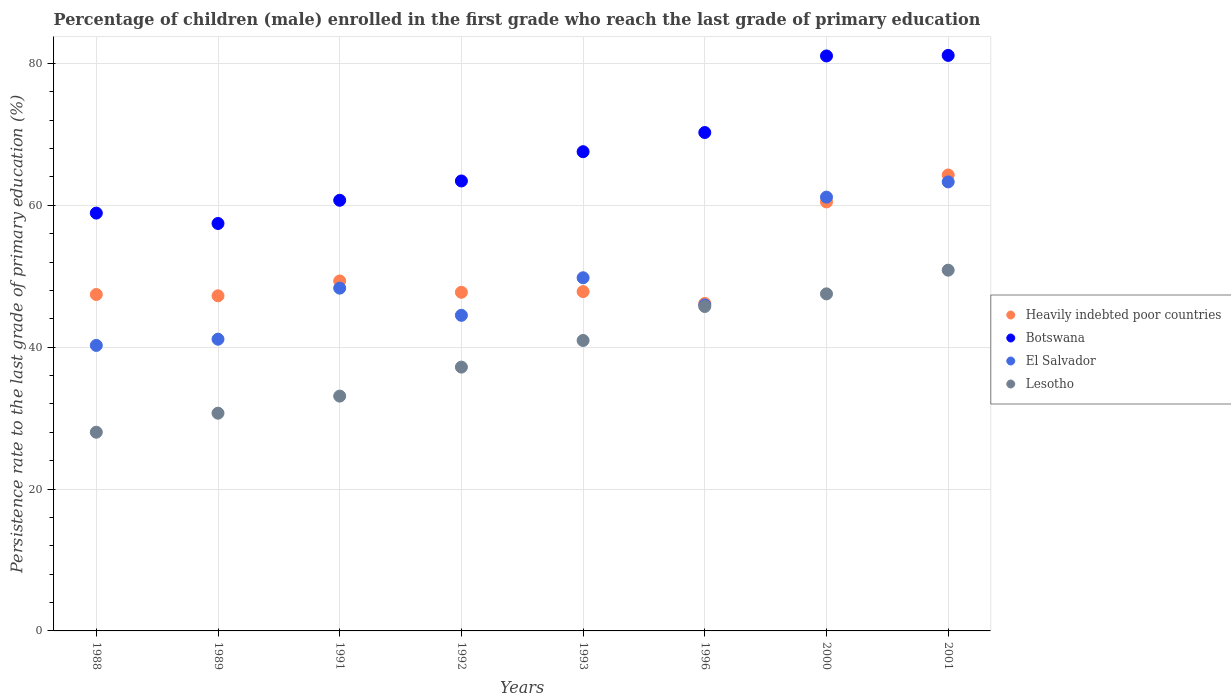How many different coloured dotlines are there?
Ensure brevity in your answer.  4. What is the persistence rate of children in Heavily indebted poor countries in 1988?
Your response must be concise. 47.42. Across all years, what is the maximum persistence rate of children in Heavily indebted poor countries?
Give a very brief answer. 64.27. Across all years, what is the minimum persistence rate of children in Lesotho?
Your answer should be compact. 28.01. In which year was the persistence rate of children in El Salvador maximum?
Give a very brief answer. 2001. In which year was the persistence rate of children in Lesotho minimum?
Ensure brevity in your answer.  1988. What is the total persistence rate of children in Heavily indebted poor countries in the graph?
Your response must be concise. 410.46. What is the difference between the persistence rate of children in Lesotho in 1991 and that in 1992?
Ensure brevity in your answer.  -4.09. What is the difference between the persistence rate of children in El Salvador in 1991 and the persistence rate of children in Botswana in 2001?
Give a very brief answer. -32.81. What is the average persistence rate of children in El Salvador per year?
Provide a succinct answer. 49.29. In the year 2000, what is the difference between the persistence rate of children in El Salvador and persistence rate of children in Heavily indebted poor countries?
Make the answer very short. 0.68. In how many years, is the persistence rate of children in Botswana greater than 76 %?
Provide a short and direct response. 2. What is the ratio of the persistence rate of children in Heavily indebted poor countries in 1988 to that in 1989?
Give a very brief answer. 1. What is the difference between the highest and the second highest persistence rate of children in Lesotho?
Your answer should be very brief. 3.34. What is the difference between the highest and the lowest persistence rate of children in Botswana?
Offer a terse response. 23.69. In how many years, is the persistence rate of children in Lesotho greater than the average persistence rate of children in Lesotho taken over all years?
Give a very brief answer. 4. Is the sum of the persistence rate of children in Heavily indebted poor countries in 1988 and 2000 greater than the maximum persistence rate of children in El Salvador across all years?
Offer a terse response. Yes. Is it the case that in every year, the sum of the persistence rate of children in Lesotho and persistence rate of children in Botswana  is greater than the sum of persistence rate of children in El Salvador and persistence rate of children in Heavily indebted poor countries?
Give a very brief answer. No. Does the persistence rate of children in El Salvador monotonically increase over the years?
Keep it short and to the point. No. Is the persistence rate of children in Heavily indebted poor countries strictly greater than the persistence rate of children in Botswana over the years?
Give a very brief answer. No. Is the persistence rate of children in Lesotho strictly less than the persistence rate of children in Heavily indebted poor countries over the years?
Offer a very short reply. Yes. How many dotlines are there?
Your answer should be very brief. 4. Are the values on the major ticks of Y-axis written in scientific E-notation?
Give a very brief answer. No. Does the graph contain any zero values?
Give a very brief answer. No. Where does the legend appear in the graph?
Ensure brevity in your answer.  Center right. What is the title of the graph?
Provide a short and direct response. Percentage of children (male) enrolled in the first grade who reach the last grade of primary education. What is the label or title of the X-axis?
Your answer should be compact. Years. What is the label or title of the Y-axis?
Make the answer very short. Persistence rate to the last grade of primary education (%). What is the Persistence rate to the last grade of primary education (%) of Heavily indebted poor countries in 1988?
Give a very brief answer. 47.42. What is the Persistence rate to the last grade of primary education (%) in Botswana in 1988?
Ensure brevity in your answer.  58.9. What is the Persistence rate to the last grade of primary education (%) in El Salvador in 1988?
Provide a short and direct response. 40.25. What is the Persistence rate to the last grade of primary education (%) of Lesotho in 1988?
Your answer should be very brief. 28.01. What is the Persistence rate to the last grade of primary education (%) of Heavily indebted poor countries in 1989?
Offer a terse response. 47.24. What is the Persistence rate to the last grade of primary education (%) of Botswana in 1989?
Ensure brevity in your answer.  57.43. What is the Persistence rate to the last grade of primary education (%) of El Salvador in 1989?
Give a very brief answer. 41.12. What is the Persistence rate to the last grade of primary education (%) in Lesotho in 1989?
Offer a very short reply. 30.69. What is the Persistence rate to the last grade of primary education (%) of Heavily indebted poor countries in 1991?
Your response must be concise. 49.33. What is the Persistence rate to the last grade of primary education (%) in Botswana in 1991?
Ensure brevity in your answer.  60.7. What is the Persistence rate to the last grade of primary education (%) in El Salvador in 1991?
Give a very brief answer. 48.32. What is the Persistence rate to the last grade of primary education (%) in Lesotho in 1991?
Your response must be concise. 33.1. What is the Persistence rate to the last grade of primary education (%) of Heavily indebted poor countries in 1992?
Give a very brief answer. 47.73. What is the Persistence rate to the last grade of primary education (%) in Botswana in 1992?
Provide a short and direct response. 63.43. What is the Persistence rate to the last grade of primary education (%) of El Salvador in 1992?
Make the answer very short. 44.49. What is the Persistence rate to the last grade of primary education (%) in Lesotho in 1992?
Your response must be concise. 37.19. What is the Persistence rate to the last grade of primary education (%) of Heavily indebted poor countries in 1993?
Make the answer very short. 47.83. What is the Persistence rate to the last grade of primary education (%) in Botswana in 1993?
Provide a succinct answer. 67.55. What is the Persistence rate to the last grade of primary education (%) in El Salvador in 1993?
Your answer should be very brief. 49.78. What is the Persistence rate to the last grade of primary education (%) in Lesotho in 1993?
Your answer should be very brief. 40.94. What is the Persistence rate to the last grade of primary education (%) of Heavily indebted poor countries in 1996?
Give a very brief answer. 46.16. What is the Persistence rate to the last grade of primary education (%) of Botswana in 1996?
Your response must be concise. 70.26. What is the Persistence rate to the last grade of primary education (%) of El Salvador in 1996?
Your answer should be compact. 45.94. What is the Persistence rate to the last grade of primary education (%) of Lesotho in 1996?
Offer a terse response. 45.73. What is the Persistence rate to the last grade of primary education (%) of Heavily indebted poor countries in 2000?
Give a very brief answer. 60.47. What is the Persistence rate to the last grade of primary education (%) in Botswana in 2000?
Your answer should be very brief. 81.05. What is the Persistence rate to the last grade of primary education (%) in El Salvador in 2000?
Your answer should be compact. 61.15. What is the Persistence rate to the last grade of primary education (%) of Lesotho in 2000?
Offer a very short reply. 47.51. What is the Persistence rate to the last grade of primary education (%) in Heavily indebted poor countries in 2001?
Ensure brevity in your answer.  64.27. What is the Persistence rate to the last grade of primary education (%) of Botswana in 2001?
Your response must be concise. 81.12. What is the Persistence rate to the last grade of primary education (%) in El Salvador in 2001?
Give a very brief answer. 63.3. What is the Persistence rate to the last grade of primary education (%) in Lesotho in 2001?
Your answer should be compact. 50.85. Across all years, what is the maximum Persistence rate to the last grade of primary education (%) in Heavily indebted poor countries?
Your answer should be very brief. 64.27. Across all years, what is the maximum Persistence rate to the last grade of primary education (%) in Botswana?
Provide a succinct answer. 81.12. Across all years, what is the maximum Persistence rate to the last grade of primary education (%) in El Salvador?
Your response must be concise. 63.3. Across all years, what is the maximum Persistence rate to the last grade of primary education (%) of Lesotho?
Offer a terse response. 50.85. Across all years, what is the minimum Persistence rate to the last grade of primary education (%) in Heavily indebted poor countries?
Offer a very short reply. 46.16. Across all years, what is the minimum Persistence rate to the last grade of primary education (%) in Botswana?
Ensure brevity in your answer.  57.43. Across all years, what is the minimum Persistence rate to the last grade of primary education (%) in El Salvador?
Your answer should be compact. 40.25. Across all years, what is the minimum Persistence rate to the last grade of primary education (%) of Lesotho?
Provide a short and direct response. 28.01. What is the total Persistence rate to the last grade of primary education (%) in Heavily indebted poor countries in the graph?
Offer a very short reply. 410.46. What is the total Persistence rate to the last grade of primary education (%) of Botswana in the graph?
Give a very brief answer. 540.44. What is the total Persistence rate to the last grade of primary education (%) in El Salvador in the graph?
Your answer should be compact. 394.34. What is the total Persistence rate to the last grade of primary education (%) in Lesotho in the graph?
Your response must be concise. 314.03. What is the difference between the Persistence rate to the last grade of primary education (%) of Heavily indebted poor countries in 1988 and that in 1989?
Provide a short and direct response. 0.18. What is the difference between the Persistence rate to the last grade of primary education (%) in Botswana in 1988 and that in 1989?
Give a very brief answer. 1.46. What is the difference between the Persistence rate to the last grade of primary education (%) in El Salvador in 1988 and that in 1989?
Keep it short and to the point. -0.88. What is the difference between the Persistence rate to the last grade of primary education (%) of Lesotho in 1988 and that in 1989?
Your response must be concise. -2.68. What is the difference between the Persistence rate to the last grade of primary education (%) of Heavily indebted poor countries in 1988 and that in 1991?
Offer a very short reply. -1.91. What is the difference between the Persistence rate to the last grade of primary education (%) of Botswana in 1988 and that in 1991?
Your answer should be very brief. -1.81. What is the difference between the Persistence rate to the last grade of primary education (%) of El Salvador in 1988 and that in 1991?
Give a very brief answer. -8.07. What is the difference between the Persistence rate to the last grade of primary education (%) of Lesotho in 1988 and that in 1991?
Offer a very short reply. -5.09. What is the difference between the Persistence rate to the last grade of primary education (%) of Heavily indebted poor countries in 1988 and that in 1992?
Your answer should be compact. -0.31. What is the difference between the Persistence rate to the last grade of primary education (%) of Botswana in 1988 and that in 1992?
Offer a terse response. -4.53. What is the difference between the Persistence rate to the last grade of primary education (%) of El Salvador in 1988 and that in 1992?
Offer a very short reply. -4.24. What is the difference between the Persistence rate to the last grade of primary education (%) in Lesotho in 1988 and that in 1992?
Offer a terse response. -9.18. What is the difference between the Persistence rate to the last grade of primary education (%) of Heavily indebted poor countries in 1988 and that in 1993?
Your answer should be compact. -0.41. What is the difference between the Persistence rate to the last grade of primary education (%) of Botswana in 1988 and that in 1993?
Provide a short and direct response. -8.65. What is the difference between the Persistence rate to the last grade of primary education (%) of El Salvador in 1988 and that in 1993?
Your response must be concise. -9.54. What is the difference between the Persistence rate to the last grade of primary education (%) in Lesotho in 1988 and that in 1993?
Give a very brief answer. -12.93. What is the difference between the Persistence rate to the last grade of primary education (%) in Heavily indebted poor countries in 1988 and that in 1996?
Offer a very short reply. 1.26. What is the difference between the Persistence rate to the last grade of primary education (%) of Botswana in 1988 and that in 1996?
Make the answer very short. -11.36. What is the difference between the Persistence rate to the last grade of primary education (%) of El Salvador in 1988 and that in 1996?
Make the answer very short. -5.7. What is the difference between the Persistence rate to the last grade of primary education (%) of Lesotho in 1988 and that in 1996?
Provide a short and direct response. -17.72. What is the difference between the Persistence rate to the last grade of primary education (%) of Heavily indebted poor countries in 1988 and that in 2000?
Your answer should be compact. -13.05. What is the difference between the Persistence rate to the last grade of primary education (%) in Botswana in 1988 and that in 2000?
Offer a terse response. -22.15. What is the difference between the Persistence rate to the last grade of primary education (%) in El Salvador in 1988 and that in 2000?
Your answer should be compact. -20.9. What is the difference between the Persistence rate to the last grade of primary education (%) of Lesotho in 1988 and that in 2000?
Keep it short and to the point. -19.5. What is the difference between the Persistence rate to the last grade of primary education (%) in Heavily indebted poor countries in 1988 and that in 2001?
Make the answer very short. -16.85. What is the difference between the Persistence rate to the last grade of primary education (%) in Botswana in 1988 and that in 2001?
Your response must be concise. -22.23. What is the difference between the Persistence rate to the last grade of primary education (%) in El Salvador in 1988 and that in 2001?
Your answer should be compact. -23.05. What is the difference between the Persistence rate to the last grade of primary education (%) of Lesotho in 1988 and that in 2001?
Provide a short and direct response. -22.84. What is the difference between the Persistence rate to the last grade of primary education (%) in Heavily indebted poor countries in 1989 and that in 1991?
Offer a very short reply. -2.09. What is the difference between the Persistence rate to the last grade of primary education (%) of Botswana in 1989 and that in 1991?
Provide a short and direct response. -3.27. What is the difference between the Persistence rate to the last grade of primary education (%) of El Salvador in 1989 and that in 1991?
Keep it short and to the point. -7.2. What is the difference between the Persistence rate to the last grade of primary education (%) in Lesotho in 1989 and that in 1991?
Give a very brief answer. -2.41. What is the difference between the Persistence rate to the last grade of primary education (%) in Heavily indebted poor countries in 1989 and that in 1992?
Ensure brevity in your answer.  -0.49. What is the difference between the Persistence rate to the last grade of primary education (%) in Botswana in 1989 and that in 1992?
Ensure brevity in your answer.  -5.99. What is the difference between the Persistence rate to the last grade of primary education (%) of El Salvador in 1989 and that in 1992?
Provide a short and direct response. -3.36. What is the difference between the Persistence rate to the last grade of primary education (%) of Lesotho in 1989 and that in 1992?
Provide a short and direct response. -6.49. What is the difference between the Persistence rate to the last grade of primary education (%) in Heavily indebted poor countries in 1989 and that in 1993?
Make the answer very short. -0.59. What is the difference between the Persistence rate to the last grade of primary education (%) of Botswana in 1989 and that in 1993?
Make the answer very short. -10.12. What is the difference between the Persistence rate to the last grade of primary education (%) in El Salvador in 1989 and that in 1993?
Provide a short and direct response. -8.66. What is the difference between the Persistence rate to the last grade of primary education (%) in Lesotho in 1989 and that in 1993?
Offer a terse response. -10.25. What is the difference between the Persistence rate to the last grade of primary education (%) of Heavily indebted poor countries in 1989 and that in 1996?
Offer a terse response. 1.08. What is the difference between the Persistence rate to the last grade of primary education (%) of Botswana in 1989 and that in 1996?
Your response must be concise. -12.82. What is the difference between the Persistence rate to the last grade of primary education (%) of El Salvador in 1989 and that in 1996?
Your response must be concise. -4.82. What is the difference between the Persistence rate to the last grade of primary education (%) in Lesotho in 1989 and that in 1996?
Your response must be concise. -15.04. What is the difference between the Persistence rate to the last grade of primary education (%) in Heavily indebted poor countries in 1989 and that in 2000?
Keep it short and to the point. -13.23. What is the difference between the Persistence rate to the last grade of primary education (%) of Botswana in 1989 and that in 2000?
Give a very brief answer. -23.62. What is the difference between the Persistence rate to the last grade of primary education (%) in El Salvador in 1989 and that in 2000?
Your response must be concise. -20.02. What is the difference between the Persistence rate to the last grade of primary education (%) of Lesotho in 1989 and that in 2000?
Keep it short and to the point. -16.82. What is the difference between the Persistence rate to the last grade of primary education (%) of Heavily indebted poor countries in 1989 and that in 2001?
Your answer should be very brief. -17.03. What is the difference between the Persistence rate to the last grade of primary education (%) in Botswana in 1989 and that in 2001?
Keep it short and to the point. -23.69. What is the difference between the Persistence rate to the last grade of primary education (%) in El Salvador in 1989 and that in 2001?
Ensure brevity in your answer.  -22.17. What is the difference between the Persistence rate to the last grade of primary education (%) of Lesotho in 1989 and that in 2001?
Offer a very short reply. -20.16. What is the difference between the Persistence rate to the last grade of primary education (%) in Heavily indebted poor countries in 1991 and that in 1992?
Give a very brief answer. 1.59. What is the difference between the Persistence rate to the last grade of primary education (%) in Botswana in 1991 and that in 1992?
Provide a short and direct response. -2.72. What is the difference between the Persistence rate to the last grade of primary education (%) of El Salvador in 1991 and that in 1992?
Your answer should be compact. 3.83. What is the difference between the Persistence rate to the last grade of primary education (%) in Lesotho in 1991 and that in 1992?
Offer a terse response. -4.09. What is the difference between the Persistence rate to the last grade of primary education (%) in Heavily indebted poor countries in 1991 and that in 1993?
Ensure brevity in your answer.  1.5. What is the difference between the Persistence rate to the last grade of primary education (%) in Botswana in 1991 and that in 1993?
Provide a succinct answer. -6.85. What is the difference between the Persistence rate to the last grade of primary education (%) in El Salvador in 1991 and that in 1993?
Your answer should be very brief. -1.46. What is the difference between the Persistence rate to the last grade of primary education (%) of Lesotho in 1991 and that in 1993?
Make the answer very short. -7.84. What is the difference between the Persistence rate to the last grade of primary education (%) of Heavily indebted poor countries in 1991 and that in 1996?
Make the answer very short. 3.17. What is the difference between the Persistence rate to the last grade of primary education (%) of Botswana in 1991 and that in 1996?
Offer a very short reply. -9.55. What is the difference between the Persistence rate to the last grade of primary education (%) of El Salvador in 1991 and that in 1996?
Provide a succinct answer. 2.38. What is the difference between the Persistence rate to the last grade of primary education (%) of Lesotho in 1991 and that in 1996?
Offer a very short reply. -12.63. What is the difference between the Persistence rate to the last grade of primary education (%) of Heavily indebted poor countries in 1991 and that in 2000?
Your answer should be compact. -11.14. What is the difference between the Persistence rate to the last grade of primary education (%) in Botswana in 1991 and that in 2000?
Offer a terse response. -20.35. What is the difference between the Persistence rate to the last grade of primary education (%) in El Salvador in 1991 and that in 2000?
Provide a succinct answer. -12.83. What is the difference between the Persistence rate to the last grade of primary education (%) of Lesotho in 1991 and that in 2000?
Your answer should be very brief. -14.41. What is the difference between the Persistence rate to the last grade of primary education (%) in Heavily indebted poor countries in 1991 and that in 2001?
Provide a succinct answer. -14.95. What is the difference between the Persistence rate to the last grade of primary education (%) in Botswana in 1991 and that in 2001?
Your answer should be very brief. -20.42. What is the difference between the Persistence rate to the last grade of primary education (%) in El Salvador in 1991 and that in 2001?
Your answer should be very brief. -14.98. What is the difference between the Persistence rate to the last grade of primary education (%) in Lesotho in 1991 and that in 2001?
Provide a short and direct response. -17.75. What is the difference between the Persistence rate to the last grade of primary education (%) of Heavily indebted poor countries in 1992 and that in 1993?
Ensure brevity in your answer.  -0.1. What is the difference between the Persistence rate to the last grade of primary education (%) in Botswana in 1992 and that in 1993?
Provide a short and direct response. -4.12. What is the difference between the Persistence rate to the last grade of primary education (%) in El Salvador in 1992 and that in 1993?
Keep it short and to the point. -5.3. What is the difference between the Persistence rate to the last grade of primary education (%) of Lesotho in 1992 and that in 1993?
Your answer should be very brief. -3.76. What is the difference between the Persistence rate to the last grade of primary education (%) of Heavily indebted poor countries in 1992 and that in 1996?
Ensure brevity in your answer.  1.57. What is the difference between the Persistence rate to the last grade of primary education (%) of Botswana in 1992 and that in 1996?
Keep it short and to the point. -6.83. What is the difference between the Persistence rate to the last grade of primary education (%) of El Salvador in 1992 and that in 1996?
Provide a succinct answer. -1.46. What is the difference between the Persistence rate to the last grade of primary education (%) of Lesotho in 1992 and that in 1996?
Ensure brevity in your answer.  -8.55. What is the difference between the Persistence rate to the last grade of primary education (%) of Heavily indebted poor countries in 1992 and that in 2000?
Your response must be concise. -12.74. What is the difference between the Persistence rate to the last grade of primary education (%) of Botswana in 1992 and that in 2000?
Provide a succinct answer. -17.62. What is the difference between the Persistence rate to the last grade of primary education (%) of El Salvador in 1992 and that in 2000?
Your answer should be very brief. -16.66. What is the difference between the Persistence rate to the last grade of primary education (%) of Lesotho in 1992 and that in 2000?
Keep it short and to the point. -10.33. What is the difference between the Persistence rate to the last grade of primary education (%) in Heavily indebted poor countries in 1992 and that in 2001?
Your response must be concise. -16.54. What is the difference between the Persistence rate to the last grade of primary education (%) in Botswana in 1992 and that in 2001?
Give a very brief answer. -17.7. What is the difference between the Persistence rate to the last grade of primary education (%) in El Salvador in 1992 and that in 2001?
Offer a very short reply. -18.81. What is the difference between the Persistence rate to the last grade of primary education (%) of Lesotho in 1992 and that in 2001?
Offer a terse response. -13.66. What is the difference between the Persistence rate to the last grade of primary education (%) of Heavily indebted poor countries in 1993 and that in 1996?
Offer a terse response. 1.67. What is the difference between the Persistence rate to the last grade of primary education (%) in Botswana in 1993 and that in 1996?
Offer a very short reply. -2.71. What is the difference between the Persistence rate to the last grade of primary education (%) of El Salvador in 1993 and that in 1996?
Offer a terse response. 3.84. What is the difference between the Persistence rate to the last grade of primary education (%) in Lesotho in 1993 and that in 1996?
Give a very brief answer. -4.79. What is the difference between the Persistence rate to the last grade of primary education (%) of Heavily indebted poor countries in 1993 and that in 2000?
Provide a short and direct response. -12.64. What is the difference between the Persistence rate to the last grade of primary education (%) in Botswana in 1993 and that in 2000?
Keep it short and to the point. -13.5. What is the difference between the Persistence rate to the last grade of primary education (%) in El Salvador in 1993 and that in 2000?
Ensure brevity in your answer.  -11.36. What is the difference between the Persistence rate to the last grade of primary education (%) in Lesotho in 1993 and that in 2000?
Provide a short and direct response. -6.57. What is the difference between the Persistence rate to the last grade of primary education (%) in Heavily indebted poor countries in 1993 and that in 2001?
Your answer should be compact. -16.44. What is the difference between the Persistence rate to the last grade of primary education (%) in Botswana in 1993 and that in 2001?
Offer a terse response. -13.57. What is the difference between the Persistence rate to the last grade of primary education (%) of El Salvador in 1993 and that in 2001?
Provide a succinct answer. -13.51. What is the difference between the Persistence rate to the last grade of primary education (%) of Lesotho in 1993 and that in 2001?
Provide a succinct answer. -9.91. What is the difference between the Persistence rate to the last grade of primary education (%) in Heavily indebted poor countries in 1996 and that in 2000?
Ensure brevity in your answer.  -14.31. What is the difference between the Persistence rate to the last grade of primary education (%) in Botswana in 1996 and that in 2000?
Your response must be concise. -10.79. What is the difference between the Persistence rate to the last grade of primary education (%) of El Salvador in 1996 and that in 2000?
Give a very brief answer. -15.2. What is the difference between the Persistence rate to the last grade of primary education (%) of Lesotho in 1996 and that in 2000?
Provide a short and direct response. -1.78. What is the difference between the Persistence rate to the last grade of primary education (%) in Heavily indebted poor countries in 1996 and that in 2001?
Your answer should be very brief. -18.11. What is the difference between the Persistence rate to the last grade of primary education (%) of Botswana in 1996 and that in 2001?
Your answer should be compact. -10.87. What is the difference between the Persistence rate to the last grade of primary education (%) of El Salvador in 1996 and that in 2001?
Make the answer very short. -17.35. What is the difference between the Persistence rate to the last grade of primary education (%) of Lesotho in 1996 and that in 2001?
Give a very brief answer. -5.12. What is the difference between the Persistence rate to the last grade of primary education (%) in Heavily indebted poor countries in 2000 and that in 2001?
Keep it short and to the point. -3.8. What is the difference between the Persistence rate to the last grade of primary education (%) in Botswana in 2000 and that in 2001?
Provide a short and direct response. -0.08. What is the difference between the Persistence rate to the last grade of primary education (%) of El Salvador in 2000 and that in 2001?
Ensure brevity in your answer.  -2.15. What is the difference between the Persistence rate to the last grade of primary education (%) of Lesotho in 2000 and that in 2001?
Offer a terse response. -3.34. What is the difference between the Persistence rate to the last grade of primary education (%) of Heavily indebted poor countries in 1988 and the Persistence rate to the last grade of primary education (%) of Botswana in 1989?
Ensure brevity in your answer.  -10.01. What is the difference between the Persistence rate to the last grade of primary education (%) in Heavily indebted poor countries in 1988 and the Persistence rate to the last grade of primary education (%) in El Salvador in 1989?
Your response must be concise. 6.3. What is the difference between the Persistence rate to the last grade of primary education (%) of Heavily indebted poor countries in 1988 and the Persistence rate to the last grade of primary education (%) of Lesotho in 1989?
Provide a succinct answer. 16.73. What is the difference between the Persistence rate to the last grade of primary education (%) of Botswana in 1988 and the Persistence rate to the last grade of primary education (%) of El Salvador in 1989?
Offer a very short reply. 17.77. What is the difference between the Persistence rate to the last grade of primary education (%) of Botswana in 1988 and the Persistence rate to the last grade of primary education (%) of Lesotho in 1989?
Offer a very short reply. 28.2. What is the difference between the Persistence rate to the last grade of primary education (%) in El Salvador in 1988 and the Persistence rate to the last grade of primary education (%) in Lesotho in 1989?
Provide a succinct answer. 9.55. What is the difference between the Persistence rate to the last grade of primary education (%) in Heavily indebted poor countries in 1988 and the Persistence rate to the last grade of primary education (%) in Botswana in 1991?
Make the answer very short. -13.28. What is the difference between the Persistence rate to the last grade of primary education (%) of Heavily indebted poor countries in 1988 and the Persistence rate to the last grade of primary education (%) of El Salvador in 1991?
Ensure brevity in your answer.  -0.9. What is the difference between the Persistence rate to the last grade of primary education (%) of Heavily indebted poor countries in 1988 and the Persistence rate to the last grade of primary education (%) of Lesotho in 1991?
Offer a very short reply. 14.32. What is the difference between the Persistence rate to the last grade of primary education (%) in Botswana in 1988 and the Persistence rate to the last grade of primary education (%) in El Salvador in 1991?
Your answer should be very brief. 10.58. What is the difference between the Persistence rate to the last grade of primary education (%) of Botswana in 1988 and the Persistence rate to the last grade of primary education (%) of Lesotho in 1991?
Give a very brief answer. 25.8. What is the difference between the Persistence rate to the last grade of primary education (%) of El Salvador in 1988 and the Persistence rate to the last grade of primary education (%) of Lesotho in 1991?
Keep it short and to the point. 7.15. What is the difference between the Persistence rate to the last grade of primary education (%) of Heavily indebted poor countries in 1988 and the Persistence rate to the last grade of primary education (%) of Botswana in 1992?
Ensure brevity in your answer.  -16. What is the difference between the Persistence rate to the last grade of primary education (%) in Heavily indebted poor countries in 1988 and the Persistence rate to the last grade of primary education (%) in El Salvador in 1992?
Your answer should be compact. 2.94. What is the difference between the Persistence rate to the last grade of primary education (%) of Heavily indebted poor countries in 1988 and the Persistence rate to the last grade of primary education (%) of Lesotho in 1992?
Offer a very short reply. 10.24. What is the difference between the Persistence rate to the last grade of primary education (%) in Botswana in 1988 and the Persistence rate to the last grade of primary education (%) in El Salvador in 1992?
Your answer should be very brief. 14.41. What is the difference between the Persistence rate to the last grade of primary education (%) in Botswana in 1988 and the Persistence rate to the last grade of primary education (%) in Lesotho in 1992?
Provide a short and direct response. 21.71. What is the difference between the Persistence rate to the last grade of primary education (%) in El Salvador in 1988 and the Persistence rate to the last grade of primary education (%) in Lesotho in 1992?
Provide a short and direct response. 3.06. What is the difference between the Persistence rate to the last grade of primary education (%) in Heavily indebted poor countries in 1988 and the Persistence rate to the last grade of primary education (%) in Botswana in 1993?
Provide a succinct answer. -20.13. What is the difference between the Persistence rate to the last grade of primary education (%) in Heavily indebted poor countries in 1988 and the Persistence rate to the last grade of primary education (%) in El Salvador in 1993?
Keep it short and to the point. -2.36. What is the difference between the Persistence rate to the last grade of primary education (%) in Heavily indebted poor countries in 1988 and the Persistence rate to the last grade of primary education (%) in Lesotho in 1993?
Provide a short and direct response. 6.48. What is the difference between the Persistence rate to the last grade of primary education (%) in Botswana in 1988 and the Persistence rate to the last grade of primary education (%) in El Salvador in 1993?
Make the answer very short. 9.11. What is the difference between the Persistence rate to the last grade of primary education (%) of Botswana in 1988 and the Persistence rate to the last grade of primary education (%) of Lesotho in 1993?
Make the answer very short. 17.95. What is the difference between the Persistence rate to the last grade of primary education (%) in El Salvador in 1988 and the Persistence rate to the last grade of primary education (%) in Lesotho in 1993?
Give a very brief answer. -0.7. What is the difference between the Persistence rate to the last grade of primary education (%) in Heavily indebted poor countries in 1988 and the Persistence rate to the last grade of primary education (%) in Botswana in 1996?
Offer a very short reply. -22.83. What is the difference between the Persistence rate to the last grade of primary education (%) in Heavily indebted poor countries in 1988 and the Persistence rate to the last grade of primary education (%) in El Salvador in 1996?
Your answer should be very brief. 1.48. What is the difference between the Persistence rate to the last grade of primary education (%) of Heavily indebted poor countries in 1988 and the Persistence rate to the last grade of primary education (%) of Lesotho in 1996?
Your response must be concise. 1.69. What is the difference between the Persistence rate to the last grade of primary education (%) of Botswana in 1988 and the Persistence rate to the last grade of primary education (%) of El Salvador in 1996?
Ensure brevity in your answer.  12.95. What is the difference between the Persistence rate to the last grade of primary education (%) of Botswana in 1988 and the Persistence rate to the last grade of primary education (%) of Lesotho in 1996?
Provide a short and direct response. 13.16. What is the difference between the Persistence rate to the last grade of primary education (%) of El Salvador in 1988 and the Persistence rate to the last grade of primary education (%) of Lesotho in 1996?
Make the answer very short. -5.49. What is the difference between the Persistence rate to the last grade of primary education (%) of Heavily indebted poor countries in 1988 and the Persistence rate to the last grade of primary education (%) of Botswana in 2000?
Your response must be concise. -33.63. What is the difference between the Persistence rate to the last grade of primary education (%) in Heavily indebted poor countries in 1988 and the Persistence rate to the last grade of primary education (%) in El Salvador in 2000?
Provide a succinct answer. -13.72. What is the difference between the Persistence rate to the last grade of primary education (%) in Heavily indebted poor countries in 1988 and the Persistence rate to the last grade of primary education (%) in Lesotho in 2000?
Make the answer very short. -0.09. What is the difference between the Persistence rate to the last grade of primary education (%) in Botswana in 1988 and the Persistence rate to the last grade of primary education (%) in El Salvador in 2000?
Offer a terse response. -2.25. What is the difference between the Persistence rate to the last grade of primary education (%) in Botswana in 1988 and the Persistence rate to the last grade of primary education (%) in Lesotho in 2000?
Provide a short and direct response. 11.38. What is the difference between the Persistence rate to the last grade of primary education (%) in El Salvador in 1988 and the Persistence rate to the last grade of primary education (%) in Lesotho in 2000?
Keep it short and to the point. -7.27. What is the difference between the Persistence rate to the last grade of primary education (%) of Heavily indebted poor countries in 1988 and the Persistence rate to the last grade of primary education (%) of Botswana in 2001?
Offer a very short reply. -33.7. What is the difference between the Persistence rate to the last grade of primary education (%) of Heavily indebted poor countries in 1988 and the Persistence rate to the last grade of primary education (%) of El Salvador in 2001?
Make the answer very short. -15.87. What is the difference between the Persistence rate to the last grade of primary education (%) of Heavily indebted poor countries in 1988 and the Persistence rate to the last grade of primary education (%) of Lesotho in 2001?
Offer a very short reply. -3.43. What is the difference between the Persistence rate to the last grade of primary education (%) in Botswana in 1988 and the Persistence rate to the last grade of primary education (%) in El Salvador in 2001?
Provide a succinct answer. -4.4. What is the difference between the Persistence rate to the last grade of primary education (%) in Botswana in 1988 and the Persistence rate to the last grade of primary education (%) in Lesotho in 2001?
Ensure brevity in your answer.  8.05. What is the difference between the Persistence rate to the last grade of primary education (%) in El Salvador in 1988 and the Persistence rate to the last grade of primary education (%) in Lesotho in 2001?
Provide a succinct answer. -10.61. What is the difference between the Persistence rate to the last grade of primary education (%) in Heavily indebted poor countries in 1989 and the Persistence rate to the last grade of primary education (%) in Botswana in 1991?
Provide a short and direct response. -13.46. What is the difference between the Persistence rate to the last grade of primary education (%) in Heavily indebted poor countries in 1989 and the Persistence rate to the last grade of primary education (%) in El Salvador in 1991?
Your answer should be very brief. -1.08. What is the difference between the Persistence rate to the last grade of primary education (%) in Heavily indebted poor countries in 1989 and the Persistence rate to the last grade of primary education (%) in Lesotho in 1991?
Give a very brief answer. 14.14. What is the difference between the Persistence rate to the last grade of primary education (%) of Botswana in 1989 and the Persistence rate to the last grade of primary education (%) of El Salvador in 1991?
Provide a succinct answer. 9.11. What is the difference between the Persistence rate to the last grade of primary education (%) in Botswana in 1989 and the Persistence rate to the last grade of primary education (%) in Lesotho in 1991?
Give a very brief answer. 24.33. What is the difference between the Persistence rate to the last grade of primary education (%) of El Salvador in 1989 and the Persistence rate to the last grade of primary education (%) of Lesotho in 1991?
Give a very brief answer. 8.02. What is the difference between the Persistence rate to the last grade of primary education (%) in Heavily indebted poor countries in 1989 and the Persistence rate to the last grade of primary education (%) in Botswana in 1992?
Provide a short and direct response. -16.19. What is the difference between the Persistence rate to the last grade of primary education (%) of Heavily indebted poor countries in 1989 and the Persistence rate to the last grade of primary education (%) of El Salvador in 1992?
Provide a short and direct response. 2.75. What is the difference between the Persistence rate to the last grade of primary education (%) in Heavily indebted poor countries in 1989 and the Persistence rate to the last grade of primary education (%) in Lesotho in 1992?
Offer a very short reply. 10.05. What is the difference between the Persistence rate to the last grade of primary education (%) of Botswana in 1989 and the Persistence rate to the last grade of primary education (%) of El Salvador in 1992?
Give a very brief answer. 12.95. What is the difference between the Persistence rate to the last grade of primary education (%) in Botswana in 1989 and the Persistence rate to the last grade of primary education (%) in Lesotho in 1992?
Your answer should be very brief. 20.25. What is the difference between the Persistence rate to the last grade of primary education (%) in El Salvador in 1989 and the Persistence rate to the last grade of primary education (%) in Lesotho in 1992?
Keep it short and to the point. 3.94. What is the difference between the Persistence rate to the last grade of primary education (%) in Heavily indebted poor countries in 1989 and the Persistence rate to the last grade of primary education (%) in Botswana in 1993?
Provide a short and direct response. -20.31. What is the difference between the Persistence rate to the last grade of primary education (%) in Heavily indebted poor countries in 1989 and the Persistence rate to the last grade of primary education (%) in El Salvador in 1993?
Make the answer very short. -2.54. What is the difference between the Persistence rate to the last grade of primary education (%) of Heavily indebted poor countries in 1989 and the Persistence rate to the last grade of primary education (%) of Lesotho in 1993?
Your answer should be compact. 6.3. What is the difference between the Persistence rate to the last grade of primary education (%) of Botswana in 1989 and the Persistence rate to the last grade of primary education (%) of El Salvador in 1993?
Give a very brief answer. 7.65. What is the difference between the Persistence rate to the last grade of primary education (%) in Botswana in 1989 and the Persistence rate to the last grade of primary education (%) in Lesotho in 1993?
Give a very brief answer. 16.49. What is the difference between the Persistence rate to the last grade of primary education (%) in El Salvador in 1989 and the Persistence rate to the last grade of primary education (%) in Lesotho in 1993?
Provide a succinct answer. 0.18. What is the difference between the Persistence rate to the last grade of primary education (%) in Heavily indebted poor countries in 1989 and the Persistence rate to the last grade of primary education (%) in Botswana in 1996?
Provide a succinct answer. -23.02. What is the difference between the Persistence rate to the last grade of primary education (%) in Heavily indebted poor countries in 1989 and the Persistence rate to the last grade of primary education (%) in El Salvador in 1996?
Keep it short and to the point. 1.3. What is the difference between the Persistence rate to the last grade of primary education (%) of Heavily indebted poor countries in 1989 and the Persistence rate to the last grade of primary education (%) of Lesotho in 1996?
Provide a short and direct response. 1.51. What is the difference between the Persistence rate to the last grade of primary education (%) in Botswana in 1989 and the Persistence rate to the last grade of primary education (%) in El Salvador in 1996?
Keep it short and to the point. 11.49. What is the difference between the Persistence rate to the last grade of primary education (%) in Botswana in 1989 and the Persistence rate to the last grade of primary education (%) in Lesotho in 1996?
Keep it short and to the point. 11.7. What is the difference between the Persistence rate to the last grade of primary education (%) of El Salvador in 1989 and the Persistence rate to the last grade of primary education (%) of Lesotho in 1996?
Offer a very short reply. -4.61. What is the difference between the Persistence rate to the last grade of primary education (%) in Heavily indebted poor countries in 1989 and the Persistence rate to the last grade of primary education (%) in Botswana in 2000?
Provide a short and direct response. -33.81. What is the difference between the Persistence rate to the last grade of primary education (%) in Heavily indebted poor countries in 1989 and the Persistence rate to the last grade of primary education (%) in El Salvador in 2000?
Offer a terse response. -13.91. What is the difference between the Persistence rate to the last grade of primary education (%) in Heavily indebted poor countries in 1989 and the Persistence rate to the last grade of primary education (%) in Lesotho in 2000?
Provide a short and direct response. -0.27. What is the difference between the Persistence rate to the last grade of primary education (%) of Botswana in 1989 and the Persistence rate to the last grade of primary education (%) of El Salvador in 2000?
Make the answer very short. -3.71. What is the difference between the Persistence rate to the last grade of primary education (%) in Botswana in 1989 and the Persistence rate to the last grade of primary education (%) in Lesotho in 2000?
Keep it short and to the point. 9.92. What is the difference between the Persistence rate to the last grade of primary education (%) in El Salvador in 1989 and the Persistence rate to the last grade of primary education (%) in Lesotho in 2000?
Offer a terse response. -6.39. What is the difference between the Persistence rate to the last grade of primary education (%) of Heavily indebted poor countries in 1989 and the Persistence rate to the last grade of primary education (%) of Botswana in 2001?
Ensure brevity in your answer.  -33.89. What is the difference between the Persistence rate to the last grade of primary education (%) in Heavily indebted poor countries in 1989 and the Persistence rate to the last grade of primary education (%) in El Salvador in 2001?
Provide a succinct answer. -16.06. What is the difference between the Persistence rate to the last grade of primary education (%) of Heavily indebted poor countries in 1989 and the Persistence rate to the last grade of primary education (%) of Lesotho in 2001?
Your answer should be very brief. -3.61. What is the difference between the Persistence rate to the last grade of primary education (%) of Botswana in 1989 and the Persistence rate to the last grade of primary education (%) of El Salvador in 2001?
Ensure brevity in your answer.  -5.86. What is the difference between the Persistence rate to the last grade of primary education (%) of Botswana in 1989 and the Persistence rate to the last grade of primary education (%) of Lesotho in 2001?
Your response must be concise. 6.58. What is the difference between the Persistence rate to the last grade of primary education (%) in El Salvador in 1989 and the Persistence rate to the last grade of primary education (%) in Lesotho in 2001?
Offer a terse response. -9.73. What is the difference between the Persistence rate to the last grade of primary education (%) of Heavily indebted poor countries in 1991 and the Persistence rate to the last grade of primary education (%) of Botswana in 1992?
Your answer should be compact. -14.1. What is the difference between the Persistence rate to the last grade of primary education (%) of Heavily indebted poor countries in 1991 and the Persistence rate to the last grade of primary education (%) of El Salvador in 1992?
Offer a very short reply. 4.84. What is the difference between the Persistence rate to the last grade of primary education (%) in Heavily indebted poor countries in 1991 and the Persistence rate to the last grade of primary education (%) in Lesotho in 1992?
Your answer should be compact. 12.14. What is the difference between the Persistence rate to the last grade of primary education (%) of Botswana in 1991 and the Persistence rate to the last grade of primary education (%) of El Salvador in 1992?
Provide a short and direct response. 16.22. What is the difference between the Persistence rate to the last grade of primary education (%) in Botswana in 1991 and the Persistence rate to the last grade of primary education (%) in Lesotho in 1992?
Give a very brief answer. 23.52. What is the difference between the Persistence rate to the last grade of primary education (%) in El Salvador in 1991 and the Persistence rate to the last grade of primary education (%) in Lesotho in 1992?
Your response must be concise. 11.13. What is the difference between the Persistence rate to the last grade of primary education (%) in Heavily indebted poor countries in 1991 and the Persistence rate to the last grade of primary education (%) in Botswana in 1993?
Keep it short and to the point. -18.22. What is the difference between the Persistence rate to the last grade of primary education (%) of Heavily indebted poor countries in 1991 and the Persistence rate to the last grade of primary education (%) of El Salvador in 1993?
Give a very brief answer. -0.45. What is the difference between the Persistence rate to the last grade of primary education (%) in Heavily indebted poor countries in 1991 and the Persistence rate to the last grade of primary education (%) in Lesotho in 1993?
Keep it short and to the point. 8.38. What is the difference between the Persistence rate to the last grade of primary education (%) of Botswana in 1991 and the Persistence rate to the last grade of primary education (%) of El Salvador in 1993?
Your answer should be very brief. 10.92. What is the difference between the Persistence rate to the last grade of primary education (%) in Botswana in 1991 and the Persistence rate to the last grade of primary education (%) in Lesotho in 1993?
Ensure brevity in your answer.  19.76. What is the difference between the Persistence rate to the last grade of primary education (%) in El Salvador in 1991 and the Persistence rate to the last grade of primary education (%) in Lesotho in 1993?
Offer a very short reply. 7.38. What is the difference between the Persistence rate to the last grade of primary education (%) in Heavily indebted poor countries in 1991 and the Persistence rate to the last grade of primary education (%) in Botswana in 1996?
Make the answer very short. -20.93. What is the difference between the Persistence rate to the last grade of primary education (%) of Heavily indebted poor countries in 1991 and the Persistence rate to the last grade of primary education (%) of El Salvador in 1996?
Make the answer very short. 3.38. What is the difference between the Persistence rate to the last grade of primary education (%) in Heavily indebted poor countries in 1991 and the Persistence rate to the last grade of primary education (%) in Lesotho in 1996?
Provide a short and direct response. 3.6. What is the difference between the Persistence rate to the last grade of primary education (%) in Botswana in 1991 and the Persistence rate to the last grade of primary education (%) in El Salvador in 1996?
Give a very brief answer. 14.76. What is the difference between the Persistence rate to the last grade of primary education (%) of Botswana in 1991 and the Persistence rate to the last grade of primary education (%) of Lesotho in 1996?
Your answer should be very brief. 14.97. What is the difference between the Persistence rate to the last grade of primary education (%) in El Salvador in 1991 and the Persistence rate to the last grade of primary education (%) in Lesotho in 1996?
Your answer should be very brief. 2.59. What is the difference between the Persistence rate to the last grade of primary education (%) in Heavily indebted poor countries in 1991 and the Persistence rate to the last grade of primary education (%) in Botswana in 2000?
Your answer should be very brief. -31.72. What is the difference between the Persistence rate to the last grade of primary education (%) in Heavily indebted poor countries in 1991 and the Persistence rate to the last grade of primary education (%) in El Salvador in 2000?
Ensure brevity in your answer.  -11.82. What is the difference between the Persistence rate to the last grade of primary education (%) of Heavily indebted poor countries in 1991 and the Persistence rate to the last grade of primary education (%) of Lesotho in 2000?
Make the answer very short. 1.81. What is the difference between the Persistence rate to the last grade of primary education (%) of Botswana in 1991 and the Persistence rate to the last grade of primary education (%) of El Salvador in 2000?
Provide a succinct answer. -0.44. What is the difference between the Persistence rate to the last grade of primary education (%) of Botswana in 1991 and the Persistence rate to the last grade of primary education (%) of Lesotho in 2000?
Offer a terse response. 13.19. What is the difference between the Persistence rate to the last grade of primary education (%) of El Salvador in 1991 and the Persistence rate to the last grade of primary education (%) of Lesotho in 2000?
Your response must be concise. 0.81. What is the difference between the Persistence rate to the last grade of primary education (%) of Heavily indebted poor countries in 1991 and the Persistence rate to the last grade of primary education (%) of Botswana in 2001?
Your answer should be compact. -31.8. What is the difference between the Persistence rate to the last grade of primary education (%) of Heavily indebted poor countries in 1991 and the Persistence rate to the last grade of primary education (%) of El Salvador in 2001?
Make the answer very short. -13.97. What is the difference between the Persistence rate to the last grade of primary education (%) of Heavily indebted poor countries in 1991 and the Persistence rate to the last grade of primary education (%) of Lesotho in 2001?
Keep it short and to the point. -1.52. What is the difference between the Persistence rate to the last grade of primary education (%) of Botswana in 1991 and the Persistence rate to the last grade of primary education (%) of El Salvador in 2001?
Provide a succinct answer. -2.59. What is the difference between the Persistence rate to the last grade of primary education (%) in Botswana in 1991 and the Persistence rate to the last grade of primary education (%) in Lesotho in 2001?
Offer a very short reply. 9.85. What is the difference between the Persistence rate to the last grade of primary education (%) in El Salvador in 1991 and the Persistence rate to the last grade of primary education (%) in Lesotho in 2001?
Your answer should be compact. -2.53. What is the difference between the Persistence rate to the last grade of primary education (%) of Heavily indebted poor countries in 1992 and the Persistence rate to the last grade of primary education (%) of Botswana in 1993?
Provide a short and direct response. -19.82. What is the difference between the Persistence rate to the last grade of primary education (%) of Heavily indebted poor countries in 1992 and the Persistence rate to the last grade of primary education (%) of El Salvador in 1993?
Offer a terse response. -2.05. What is the difference between the Persistence rate to the last grade of primary education (%) of Heavily indebted poor countries in 1992 and the Persistence rate to the last grade of primary education (%) of Lesotho in 1993?
Give a very brief answer. 6.79. What is the difference between the Persistence rate to the last grade of primary education (%) in Botswana in 1992 and the Persistence rate to the last grade of primary education (%) in El Salvador in 1993?
Your answer should be compact. 13.64. What is the difference between the Persistence rate to the last grade of primary education (%) in Botswana in 1992 and the Persistence rate to the last grade of primary education (%) in Lesotho in 1993?
Ensure brevity in your answer.  22.48. What is the difference between the Persistence rate to the last grade of primary education (%) in El Salvador in 1992 and the Persistence rate to the last grade of primary education (%) in Lesotho in 1993?
Offer a very short reply. 3.54. What is the difference between the Persistence rate to the last grade of primary education (%) in Heavily indebted poor countries in 1992 and the Persistence rate to the last grade of primary education (%) in Botswana in 1996?
Provide a short and direct response. -22.52. What is the difference between the Persistence rate to the last grade of primary education (%) in Heavily indebted poor countries in 1992 and the Persistence rate to the last grade of primary education (%) in El Salvador in 1996?
Offer a very short reply. 1.79. What is the difference between the Persistence rate to the last grade of primary education (%) of Heavily indebted poor countries in 1992 and the Persistence rate to the last grade of primary education (%) of Lesotho in 1996?
Provide a short and direct response. 2. What is the difference between the Persistence rate to the last grade of primary education (%) of Botswana in 1992 and the Persistence rate to the last grade of primary education (%) of El Salvador in 1996?
Provide a succinct answer. 17.48. What is the difference between the Persistence rate to the last grade of primary education (%) of Botswana in 1992 and the Persistence rate to the last grade of primary education (%) of Lesotho in 1996?
Your answer should be compact. 17.69. What is the difference between the Persistence rate to the last grade of primary education (%) of El Salvador in 1992 and the Persistence rate to the last grade of primary education (%) of Lesotho in 1996?
Keep it short and to the point. -1.25. What is the difference between the Persistence rate to the last grade of primary education (%) of Heavily indebted poor countries in 1992 and the Persistence rate to the last grade of primary education (%) of Botswana in 2000?
Your answer should be very brief. -33.31. What is the difference between the Persistence rate to the last grade of primary education (%) of Heavily indebted poor countries in 1992 and the Persistence rate to the last grade of primary education (%) of El Salvador in 2000?
Your response must be concise. -13.41. What is the difference between the Persistence rate to the last grade of primary education (%) of Heavily indebted poor countries in 1992 and the Persistence rate to the last grade of primary education (%) of Lesotho in 2000?
Offer a very short reply. 0.22. What is the difference between the Persistence rate to the last grade of primary education (%) in Botswana in 1992 and the Persistence rate to the last grade of primary education (%) in El Salvador in 2000?
Offer a very short reply. 2.28. What is the difference between the Persistence rate to the last grade of primary education (%) in Botswana in 1992 and the Persistence rate to the last grade of primary education (%) in Lesotho in 2000?
Provide a succinct answer. 15.91. What is the difference between the Persistence rate to the last grade of primary education (%) in El Salvador in 1992 and the Persistence rate to the last grade of primary education (%) in Lesotho in 2000?
Offer a terse response. -3.03. What is the difference between the Persistence rate to the last grade of primary education (%) in Heavily indebted poor countries in 1992 and the Persistence rate to the last grade of primary education (%) in Botswana in 2001?
Your answer should be compact. -33.39. What is the difference between the Persistence rate to the last grade of primary education (%) in Heavily indebted poor countries in 1992 and the Persistence rate to the last grade of primary education (%) in El Salvador in 2001?
Your answer should be very brief. -15.56. What is the difference between the Persistence rate to the last grade of primary education (%) in Heavily indebted poor countries in 1992 and the Persistence rate to the last grade of primary education (%) in Lesotho in 2001?
Give a very brief answer. -3.12. What is the difference between the Persistence rate to the last grade of primary education (%) in Botswana in 1992 and the Persistence rate to the last grade of primary education (%) in El Salvador in 2001?
Make the answer very short. 0.13. What is the difference between the Persistence rate to the last grade of primary education (%) in Botswana in 1992 and the Persistence rate to the last grade of primary education (%) in Lesotho in 2001?
Offer a terse response. 12.57. What is the difference between the Persistence rate to the last grade of primary education (%) in El Salvador in 1992 and the Persistence rate to the last grade of primary education (%) in Lesotho in 2001?
Offer a very short reply. -6.37. What is the difference between the Persistence rate to the last grade of primary education (%) in Heavily indebted poor countries in 1993 and the Persistence rate to the last grade of primary education (%) in Botswana in 1996?
Your answer should be compact. -22.42. What is the difference between the Persistence rate to the last grade of primary education (%) in Heavily indebted poor countries in 1993 and the Persistence rate to the last grade of primary education (%) in El Salvador in 1996?
Provide a short and direct response. 1.89. What is the difference between the Persistence rate to the last grade of primary education (%) in Heavily indebted poor countries in 1993 and the Persistence rate to the last grade of primary education (%) in Lesotho in 1996?
Offer a very short reply. 2.1. What is the difference between the Persistence rate to the last grade of primary education (%) in Botswana in 1993 and the Persistence rate to the last grade of primary education (%) in El Salvador in 1996?
Your response must be concise. 21.61. What is the difference between the Persistence rate to the last grade of primary education (%) of Botswana in 1993 and the Persistence rate to the last grade of primary education (%) of Lesotho in 1996?
Provide a short and direct response. 21.82. What is the difference between the Persistence rate to the last grade of primary education (%) in El Salvador in 1993 and the Persistence rate to the last grade of primary education (%) in Lesotho in 1996?
Your answer should be compact. 4.05. What is the difference between the Persistence rate to the last grade of primary education (%) of Heavily indebted poor countries in 1993 and the Persistence rate to the last grade of primary education (%) of Botswana in 2000?
Your answer should be compact. -33.22. What is the difference between the Persistence rate to the last grade of primary education (%) in Heavily indebted poor countries in 1993 and the Persistence rate to the last grade of primary education (%) in El Salvador in 2000?
Make the answer very short. -13.32. What is the difference between the Persistence rate to the last grade of primary education (%) in Heavily indebted poor countries in 1993 and the Persistence rate to the last grade of primary education (%) in Lesotho in 2000?
Offer a terse response. 0.32. What is the difference between the Persistence rate to the last grade of primary education (%) of Botswana in 1993 and the Persistence rate to the last grade of primary education (%) of El Salvador in 2000?
Your answer should be compact. 6.4. What is the difference between the Persistence rate to the last grade of primary education (%) in Botswana in 1993 and the Persistence rate to the last grade of primary education (%) in Lesotho in 2000?
Offer a very short reply. 20.04. What is the difference between the Persistence rate to the last grade of primary education (%) of El Salvador in 1993 and the Persistence rate to the last grade of primary education (%) of Lesotho in 2000?
Your response must be concise. 2.27. What is the difference between the Persistence rate to the last grade of primary education (%) of Heavily indebted poor countries in 1993 and the Persistence rate to the last grade of primary education (%) of Botswana in 2001?
Your answer should be compact. -33.29. What is the difference between the Persistence rate to the last grade of primary education (%) in Heavily indebted poor countries in 1993 and the Persistence rate to the last grade of primary education (%) in El Salvador in 2001?
Offer a terse response. -15.46. What is the difference between the Persistence rate to the last grade of primary education (%) in Heavily indebted poor countries in 1993 and the Persistence rate to the last grade of primary education (%) in Lesotho in 2001?
Ensure brevity in your answer.  -3.02. What is the difference between the Persistence rate to the last grade of primary education (%) of Botswana in 1993 and the Persistence rate to the last grade of primary education (%) of El Salvador in 2001?
Provide a succinct answer. 4.25. What is the difference between the Persistence rate to the last grade of primary education (%) of Botswana in 1993 and the Persistence rate to the last grade of primary education (%) of Lesotho in 2001?
Your answer should be very brief. 16.7. What is the difference between the Persistence rate to the last grade of primary education (%) in El Salvador in 1993 and the Persistence rate to the last grade of primary education (%) in Lesotho in 2001?
Provide a succinct answer. -1.07. What is the difference between the Persistence rate to the last grade of primary education (%) of Heavily indebted poor countries in 1996 and the Persistence rate to the last grade of primary education (%) of Botswana in 2000?
Offer a terse response. -34.89. What is the difference between the Persistence rate to the last grade of primary education (%) in Heavily indebted poor countries in 1996 and the Persistence rate to the last grade of primary education (%) in El Salvador in 2000?
Your answer should be compact. -14.99. What is the difference between the Persistence rate to the last grade of primary education (%) of Heavily indebted poor countries in 1996 and the Persistence rate to the last grade of primary education (%) of Lesotho in 2000?
Keep it short and to the point. -1.35. What is the difference between the Persistence rate to the last grade of primary education (%) of Botswana in 1996 and the Persistence rate to the last grade of primary education (%) of El Salvador in 2000?
Offer a terse response. 9.11. What is the difference between the Persistence rate to the last grade of primary education (%) in Botswana in 1996 and the Persistence rate to the last grade of primary education (%) in Lesotho in 2000?
Your response must be concise. 22.74. What is the difference between the Persistence rate to the last grade of primary education (%) of El Salvador in 1996 and the Persistence rate to the last grade of primary education (%) of Lesotho in 2000?
Provide a succinct answer. -1.57. What is the difference between the Persistence rate to the last grade of primary education (%) in Heavily indebted poor countries in 1996 and the Persistence rate to the last grade of primary education (%) in Botswana in 2001?
Give a very brief answer. -34.96. What is the difference between the Persistence rate to the last grade of primary education (%) of Heavily indebted poor countries in 1996 and the Persistence rate to the last grade of primary education (%) of El Salvador in 2001?
Make the answer very short. -17.13. What is the difference between the Persistence rate to the last grade of primary education (%) in Heavily indebted poor countries in 1996 and the Persistence rate to the last grade of primary education (%) in Lesotho in 2001?
Offer a terse response. -4.69. What is the difference between the Persistence rate to the last grade of primary education (%) of Botswana in 1996 and the Persistence rate to the last grade of primary education (%) of El Salvador in 2001?
Provide a succinct answer. 6.96. What is the difference between the Persistence rate to the last grade of primary education (%) in Botswana in 1996 and the Persistence rate to the last grade of primary education (%) in Lesotho in 2001?
Make the answer very short. 19.4. What is the difference between the Persistence rate to the last grade of primary education (%) in El Salvador in 1996 and the Persistence rate to the last grade of primary education (%) in Lesotho in 2001?
Keep it short and to the point. -4.91. What is the difference between the Persistence rate to the last grade of primary education (%) of Heavily indebted poor countries in 2000 and the Persistence rate to the last grade of primary education (%) of Botswana in 2001?
Offer a terse response. -20.65. What is the difference between the Persistence rate to the last grade of primary education (%) of Heavily indebted poor countries in 2000 and the Persistence rate to the last grade of primary education (%) of El Salvador in 2001?
Keep it short and to the point. -2.82. What is the difference between the Persistence rate to the last grade of primary education (%) of Heavily indebted poor countries in 2000 and the Persistence rate to the last grade of primary education (%) of Lesotho in 2001?
Ensure brevity in your answer.  9.62. What is the difference between the Persistence rate to the last grade of primary education (%) in Botswana in 2000 and the Persistence rate to the last grade of primary education (%) in El Salvador in 2001?
Give a very brief answer. 17.75. What is the difference between the Persistence rate to the last grade of primary education (%) in Botswana in 2000 and the Persistence rate to the last grade of primary education (%) in Lesotho in 2001?
Ensure brevity in your answer.  30.2. What is the difference between the Persistence rate to the last grade of primary education (%) of El Salvador in 2000 and the Persistence rate to the last grade of primary education (%) of Lesotho in 2001?
Your answer should be compact. 10.3. What is the average Persistence rate to the last grade of primary education (%) of Heavily indebted poor countries per year?
Provide a short and direct response. 51.31. What is the average Persistence rate to the last grade of primary education (%) of Botswana per year?
Ensure brevity in your answer.  67.56. What is the average Persistence rate to the last grade of primary education (%) of El Salvador per year?
Give a very brief answer. 49.29. What is the average Persistence rate to the last grade of primary education (%) of Lesotho per year?
Provide a succinct answer. 39.25. In the year 1988, what is the difference between the Persistence rate to the last grade of primary education (%) in Heavily indebted poor countries and Persistence rate to the last grade of primary education (%) in Botswana?
Offer a very short reply. -11.47. In the year 1988, what is the difference between the Persistence rate to the last grade of primary education (%) in Heavily indebted poor countries and Persistence rate to the last grade of primary education (%) in El Salvador?
Your answer should be compact. 7.18. In the year 1988, what is the difference between the Persistence rate to the last grade of primary education (%) in Heavily indebted poor countries and Persistence rate to the last grade of primary education (%) in Lesotho?
Provide a succinct answer. 19.41. In the year 1988, what is the difference between the Persistence rate to the last grade of primary education (%) of Botswana and Persistence rate to the last grade of primary education (%) of El Salvador?
Give a very brief answer. 18.65. In the year 1988, what is the difference between the Persistence rate to the last grade of primary education (%) in Botswana and Persistence rate to the last grade of primary education (%) in Lesotho?
Provide a short and direct response. 30.89. In the year 1988, what is the difference between the Persistence rate to the last grade of primary education (%) in El Salvador and Persistence rate to the last grade of primary education (%) in Lesotho?
Offer a very short reply. 12.24. In the year 1989, what is the difference between the Persistence rate to the last grade of primary education (%) of Heavily indebted poor countries and Persistence rate to the last grade of primary education (%) of Botswana?
Offer a terse response. -10.19. In the year 1989, what is the difference between the Persistence rate to the last grade of primary education (%) of Heavily indebted poor countries and Persistence rate to the last grade of primary education (%) of El Salvador?
Give a very brief answer. 6.12. In the year 1989, what is the difference between the Persistence rate to the last grade of primary education (%) in Heavily indebted poor countries and Persistence rate to the last grade of primary education (%) in Lesotho?
Give a very brief answer. 16.55. In the year 1989, what is the difference between the Persistence rate to the last grade of primary education (%) of Botswana and Persistence rate to the last grade of primary education (%) of El Salvador?
Provide a short and direct response. 16.31. In the year 1989, what is the difference between the Persistence rate to the last grade of primary education (%) in Botswana and Persistence rate to the last grade of primary education (%) in Lesotho?
Offer a very short reply. 26.74. In the year 1989, what is the difference between the Persistence rate to the last grade of primary education (%) in El Salvador and Persistence rate to the last grade of primary education (%) in Lesotho?
Your response must be concise. 10.43. In the year 1991, what is the difference between the Persistence rate to the last grade of primary education (%) of Heavily indebted poor countries and Persistence rate to the last grade of primary education (%) of Botswana?
Your answer should be very brief. -11.38. In the year 1991, what is the difference between the Persistence rate to the last grade of primary education (%) in Heavily indebted poor countries and Persistence rate to the last grade of primary education (%) in El Salvador?
Provide a short and direct response. 1.01. In the year 1991, what is the difference between the Persistence rate to the last grade of primary education (%) of Heavily indebted poor countries and Persistence rate to the last grade of primary education (%) of Lesotho?
Your answer should be very brief. 16.23. In the year 1991, what is the difference between the Persistence rate to the last grade of primary education (%) of Botswana and Persistence rate to the last grade of primary education (%) of El Salvador?
Offer a terse response. 12.38. In the year 1991, what is the difference between the Persistence rate to the last grade of primary education (%) in Botswana and Persistence rate to the last grade of primary education (%) in Lesotho?
Provide a short and direct response. 27.6. In the year 1991, what is the difference between the Persistence rate to the last grade of primary education (%) of El Salvador and Persistence rate to the last grade of primary education (%) of Lesotho?
Provide a short and direct response. 15.22. In the year 1992, what is the difference between the Persistence rate to the last grade of primary education (%) in Heavily indebted poor countries and Persistence rate to the last grade of primary education (%) in Botswana?
Your answer should be compact. -15.69. In the year 1992, what is the difference between the Persistence rate to the last grade of primary education (%) in Heavily indebted poor countries and Persistence rate to the last grade of primary education (%) in El Salvador?
Provide a short and direct response. 3.25. In the year 1992, what is the difference between the Persistence rate to the last grade of primary education (%) of Heavily indebted poor countries and Persistence rate to the last grade of primary education (%) of Lesotho?
Provide a short and direct response. 10.55. In the year 1992, what is the difference between the Persistence rate to the last grade of primary education (%) of Botswana and Persistence rate to the last grade of primary education (%) of El Salvador?
Offer a very short reply. 18.94. In the year 1992, what is the difference between the Persistence rate to the last grade of primary education (%) in Botswana and Persistence rate to the last grade of primary education (%) in Lesotho?
Give a very brief answer. 26.24. In the year 1992, what is the difference between the Persistence rate to the last grade of primary education (%) of El Salvador and Persistence rate to the last grade of primary education (%) of Lesotho?
Provide a succinct answer. 7.3. In the year 1993, what is the difference between the Persistence rate to the last grade of primary education (%) in Heavily indebted poor countries and Persistence rate to the last grade of primary education (%) in Botswana?
Provide a short and direct response. -19.72. In the year 1993, what is the difference between the Persistence rate to the last grade of primary education (%) in Heavily indebted poor countries and Persistence rate to the last grade of primary education (%) in El Salvador?
Your response must be concise. -1.95. In the year 1993, what is the difference between the Persistence rate to the last grade of primary education (%) of Heavily indebted poor countries and Persistence rate to the last grade of primary education (%) of Lesotho?
Provide a succinct answer. 6.89. In the year 1993, what is the difference between the Persistence rate to the last grade of primary education (%) of Botswana and Persistence rate to the last grade of primary education (%) of El Salvador?
Keep it short and to the point. 17.77. In the year 1993, what is the difference between the Persistence rate to the last grade of primary education (%) in Botswana and Persistence rate to the last grade of primary education (%) in Lesotho?
Your response must be concise. 26.61. In the year 1993, what is the difference between the Persistence rate to the last grade of primary education (%) of El Salvador and Persistence rate to the last grade of primary education (%) of Lesotho?
Make the answer very short. 8.84. In the year 1996, what is the difference between the Persistence rate to the last grade of primary education (%) of Heavily indebted poor countries and Persistence rate to the last grade of primary education (%) of Botswana?
Keep it short and to the point. -24.09. In the year 1996, what is the difference between the Persistence rate to the last grade of primary education (%) of Heavily indebted poor countries and Persistence rate to the last grade of primary education (%) of El Salvador?
Give a very brief answer. 0.22. In the year 1996, what is the difference between the Persistence rate to the last grade of primary education (%) of Heavily indebted poor countries and Persistence rate to the last grade of primary education (%) of Lesotho?
Ensure brevity in your answer.  0.43. In the year 1996, what is the difference between the Persistence rate to the last grade of primary education (%) of Botswana and Persistence rate to the last grade of primary education (%) of El Salvador?
Your answer should be compact. 24.31. In the year 1996, what is the difference between the Persistence rate to the last grade of primary education (%) in Botswana and Persistence rate to the last grade of primary education (%) in Lesotho?
Offer a terse response. 24.52. In the year 1996, what is the difference between the Persistence rate to the last grade of primary education (%) in El Salvador and Persistence rate to the last grade of primary education (%) in Lesotho?
Your answer should be very brief. 0.21. In the year 2000, what is the difference between the Persistence rate to the last grade of primary education (%) of Heavily indebted poor countries and Persistence rate to the last grade of primary education (%) of Botswana?
Offer a very short reply. -20.58. In the year 2000, what is the difference between the Persistence rate to the last grade of primary education (%) of Heavily indebted poor countries and Persistence rate to the last grade of primary education (%) of El Salvador?
Your response must be concise. -0.68. In the year 2000, what is the difference between the Persistence rate to the last grade of primary education (%) in Heavily indebted poor countries and Persistence rate to the last grade of primary education (%) in Lesotho?
Provide a short and direct response. 12.96. In the year 2000, what is the difference between the Persistence rate to the last grade of primary education (%) in Botswana and Persistence rate to the last grade of primary education (%) in El Salvador?
Make the answer very short. 19.9. In the year 2000, what is the difference between the Persistence rate to the last grade of primary education (%) in Botswana and Persistence rate to the last grade of primary education (%) in Lesotho?
Offer a terse response. 33.54. In the year 2000, what is the difference between the Persistence rate to the last grade of primary education (%) of El Salvador and Persistence rate to the last grade of primary education (%) of Lesotho?
Your answer should be compact. 13.63. In the year 2001, what is the difference between the Persistence rate to the last grade of primary education (%) of Heavily indebted poor countries and Persistence rate to the last grade of primary education (%) of Botswana?
Provide a short and direct response. -16.85. In the year 2001, what is the difference between the Persistence rate to the last grade of primary education (%) in Heavily indebted poor countries and Persistence rate to the last grade of primary education (%) in El Salvador?
Offer a very short reply. 0.98. In the year 2001, what is the difference between the Persistence rate to the last grade of primary education (%) of Heavily indebted poor countries and Persistence rate to the last grade of primary education (%) of Lesotho?
Provide a short and direct response. 13.42. In the year 2001, what is the difference between the Persistence rate to the last grade of primary education (%) of Botswana and Persistence rate to the last grade of primary education (%) of El Salvador?
Ensure brevity in your answer.  17.83. In the year 2001, what is the difference between the Persistence rate to the last grade of primary education (%) in Botswana and Persistence rate to the last grade of primary education (%) in Lesotho?
Your response must be concise. 30.27. In the year 2001, what is the difference between the Persistence rate to the last grade of primary education (%) of El Salvador and Persistence rate to the last grade of primary education (%) of Lesotho?
Your answer should be compact. 12.44. What is the ratio of the Persistence rate to the last grade of primary education (%) of Heavily indebted poor countries in 1988 to that in 1989?
Offer a very short reply. 1. What is the ratio of the Persistence rate to the last grade of primary education (%) of Botswana in 1988 to that in 1989?
Give a very brief answer. 1.03. What is the ratio of the Persistence rate to the last grade of primary education (%) in El Salvador in 1988 to that in 1989?
Offer a terse response. 0.98. What is the ratio of the Persistence rate to the last grade of primary education (%) in Lesotho in 1988 to that in 1989?
Provide a succinct answer. 0.91. What is the ratio of the Persistence rate to the last grade of primary education (%) of Heavily indebted poor countries in 1988 to that in 1991?
Ensure brevity in your answer.  0.96. What is the ratio of the Persistence rate to the last grade of primary education (%) of Botswana in 1988 to that in 1991?
Your answer should be very brief. 0.97. What is the ratio of the Persistence rate to the last grade of primary education (%) of El Salvador in 1988 to that in 1991?
Keep it short and to the point. 0.83. What is the ratio of the Persistence rate to the last grade of primary education (%) in Lesotho in 1988 to that in 1991?
Make the answer very short. 0.85. What is the ratio of the Persistence rate to the last grade of primary education (%) of Heavily indebted poor countries in 1988 to that in 1992?
Give a very brief answer. 0.99. What is the ratio of the Persistence rate to the last grade of primary education (%) of Botswana in 1988 to that in 1992?
Provide a short and direct response. 0.93. What is the ratio of the Persistence rate to the last grade of primary education (%) of El Salvador in 1988 to that in 1992?
Provide a short and direct response. 0.9. What is the ratio of the Persistence rate to the last grade of primary education (%) in Lesotho in 1988 to that in 1992?
Provide a short and direct response. 0.75. What is the ratio of the Persistence rate to the last grade of primary education (%) in Botswana in 1988 to that in 1993?
Your response must be concise. 0.87. What is the ratio of the Persistence rate to the last grade of primary education (%) of El Salvador in 1988 to that in 1993?
Your response must be concise. 0.81. What is the ratio of the Persistence rate to the last grade of primary education (%) in Lesotho in 1988 to that in 1993?
Provide a succinct answer. 0.68. What is the ratio of the Persistence rate to the last grade of primary education (%) in Heavily indebted poor countries in 1988 to that in 1996?
Give a very brief answer. 1.03. What is the ratio of the Persistence rate to the last grade of primary education (%) of Botswana in 1988 to that in 1996?
Give a very brief answer. 0.84. What is the ratio of the Persistence rate to the last grade of primary education (%) in El Salvador in 1988 to that in 1996?
Offer a very short reply. 0.88. What is the ratio of the Persistence rate to the last grade of primary education (%) of Lesotho in 1988 to that in 1996?
Offer a very short reply. 0.61. What is the ratio of the Persistence rate to the last grade of primary education (%) in Heavily indebted poor countries in 1988 to that in 2000?
Your answer should be very brief. 0.78. What is the ratio of the Persistence rate to the last grade of primary education (%) of Botswana in 1988 to that in 2000?
Keep it short and to the point. 0.73. What is the ratio of the Persistence rate to the last grade of primary education (%) in El Salvador in 1988 to that in 2000?
Provide a succinct answer. 0.66. What is the ratio of the Persistence rate to the last grade of primary education (%) in Lesotho in 1988 to that in 2000?
Provide a short and direct response. 0.59. What is the ratio of the Persistence rate to the last grade of primary education (%) of Heavily indebted poor countries in 1988 to that in 2001?
Offer a terse response. 0.74. What is the ratio of the Persistence rate to the last grade of primary education (%) in Botswana in 1988 to that in 2001?
Your answer should be very brief. 0.73. What is the ratio of the Persistence rate to the last grade of primary education (%) of El Salvador in 1988 to that in 2001?
Provide a short and direct response. 0.64. What is the ratio of the Persistence rate to the last grade of primary education (%) of Lesotho in 1988 to that in 2001?
Ensure brevity in your answer.  0.55. What is the ratio of the Persistence rate to the last grade of primary education (%) of Heavily indebted poor countries in 1989 to that in 1991?
Offer a very short reply. 0.96. What is the ratio of the Persistence rate to the last grade of primary education (%) of Botswana in 1989 to that in 1991?
Keep it short and to the point. 0.95. What is the ratio of the Persistence rate to the last grade of primary education (%) in El Salvador in 1989 to that in 1991?
Keep it short and to the point. 0.85. What is the ratio of the Persistence rate to the last grade of primary education (%) in Lesotho in 1989 to that in 1991?
Make the answer very short. 0.93. What is the ratio of the Persistence rate to the last grade of primary education (%) in Botswana in 1989 to that in 1992?
Your answer should be compact. 0.91. What is the ratio of the Persistence rate to the last grade of primary education (%) in El Salvador in 1989 to that in 1992?
Ensure brevity in your answer.  0.92. What is the ratio of the Persistence rate to the last grade of primary education (%) of Lesotho in 1989 to that in 1992?
Give a very brief answer. 0.83. What is the ratio of the Persistence rate to the last grade of primary education (%) of Heavily indebted poor countries in 1989 to that in 1993?
Keep it short and to the point. 0.99. What is the ratio of the Persistence rate to the last grade of primary education (%) of Botswana in 1989 to that in 1993?
Your answer should be very brief. 0.85. What is the ratio of the Persistence rate to the last grade of primary education (%) in El Salvador in 1989 to that in 1993?
Your answer should be compact. 0.83. What is the ratio of the Persistence rate to the last grade of primary education (%) of Lesotho in 1989 to that in 1993?
Provide a succinct answer. 0.75. What is the ratio of the Persistence rate to the last grade of primary education (%) in Heavily indebted poor countries in 1989 to that in 1996?
Offer a terse response. 1.02. What is the ratio of the Persistence rate to the last grade of primary education (%) of Botswana in 1989 to that in 1996?
Ensure brevity in your answer.  0.82. What is the ratio of the Persistence rate to the last grade of primary education (%) of El Salvador in 1989 to that in 1996?
Offer a very short reply. 0.9. What is the ratio of the Persistence rate to the last grade of primary education (%) of Lesotho in 1989 to that in 1996?
Keep it short and to the point. 0.67. What is the ratio of the Persistence rate to the last grade of primary education (%) in Heavily indebted poor countries in 1989 to that in 2000?
Make the answer very short. 0.78. What is the ratio of the Persistence rate to the last grade of primary education (%) of Botswana in 1989 to that in 2000?
Your answer should be compact. 0.71. What is the ratio of the Persistence rate to the last grade of primary education (%) in El Salvador in 1989 to that in 2000?
Your response must be concise. 0.67. What is the ratio of the Persistence rate to the last grade of primary education (%) of Lesotho in 1989 to that in 2000?
Make the answer very short. 0.65. What is the ratio of the Persistence rate to the last grade of primary education (%) of Heavily indebted poor countries in 1989 to that in 2001?
Provide a succinct answer. 0.73. What is the ratio of the Persistence rate to the last grade of primary education (%) in Botswana in 1989 to that in 2001?
Provide a succinct answer. 0.71. What is the ratio of the Persistence rate to the last grade of primary education (%) of El Salvador in 1989 to that in 2001?
Offer a terse response. 0.65. What is the ratio of the Persistence rate to the last grade of primary education (%) in Lesotho in 1989 to that in 2001?
Offer a terse response. 0.6. What is the ratio of the Persistence rate to the last grade of primary education (%) in Heavily indebted poor countries in 1991 to that in 1992?
Offer a terse response. 1.03. What is the ratio of the Persistence rate to the last grade of primary education (%) of Botswana in 1991 to that in 1992?
Provide a short and direct response. 0.96. What is the ratio of the Persistence rate to the last grade of primary education (%) in El Salvador in 1991 to that in 1992?
Provide a succinct answer. 1.09. What is the ratio of the Persistence rate to the last grade of primary education (%) in Lesotho in 1991 to that in 1992?
Your answer should be very brief. 0.89. What is the ratio of the Persistence rate to the last grade of primary education (%) in Heavily indebted poor countries in 1991 to that in 1993?
Provide a succinct answer. 1.03. What is the ratio of the Persistence rate to the last grade of primary education (%) of Botswana in 1991 to that in 1993?
Offer a very short reply. 0.9. What is the ratio of the Persistence rate to the last grade of primary education (%) of El Salvador in 1991 to that in 1993?
Provide a succinct answer. 0.97. What is the ratio of the Persistence rate to the last grade of primary education (%) of Lesotho in 1991 to that in 1993?
Your answer should be very brief. 0.81. What is the ratio of the Persistence rate to the last grade of primary education (%) of Heavily indebted poor countries in 1991 to that in 1996?
Your response must be concise. 1.07. What is the ratio of the Persistence rate to the last grade of primary education (%) of Botswana in 1991 to that in 1996?
Provide a succinct answer. 0.86. What is the ratio of the Persistence rate to the last grade of primary education (%) of El Salvador in 1991 to that in 1996?
Make the answer very short. 1.05. What is the ratio of the Persistence rate to the last grade of primary education (%) of Lesotho in 1991 to that in 1996?
Provide a short and direct response. 0.72. What is the ratio of the Persistence rate to the last grade of primary education (%) of Heavily indebted poor countries in 1991 to that in 2000?
Your answer should be compact. 0.82. What is the ratio of the Persistence rate to the last grade of primary education (%) of Botswana in 1991 to that in 2000?
Offer a very short reply. 0.75. What is the ratio of the Persistence rate to the last grade of primary education (%) of El Salvador in 1991 to that in 2000?
Your answer should be compact. 0.79. What is the ratio of the Persistence rate to the last grade of primary education (%) in Lesotho in 1991 to that in 2000?
Provide a short and direct response. 0.7. What is the ratio of the Persistence rate to the last grade of primary education (%) in Heavily indebted poor countries in 1991 to that in 2001?
Give a very brief answer. 0.77. What is the ratio of the Persistence rate to the last grade of primary education (%) in Botswana in 1991 to that in 2001?
Provide a succinct answer. 0.75. What is the ratio of the Persistence rate to the last grade of primary education (%) of El Salvador in 1991 to that in 2001?
Provide a short and direct response. 0.76. What is the ratio of the Persistence rate to the last grade of primary education (%) in Lesotho in 1991 to that in 2001?
Your answer should be compact. 0.65. What is the ratio of the Persistence rate to the last grade of primary education (%) in Botswana in 1992 to that in 1993?
Make the answer very short. 0.94. What is the ratio of the Persistence rate to the last grade of primary education (%) in El Salvador in 1992 to that in 1993?
Make the answer very short. 0.89. What is the ratio of the Persistence rate to the last grade of primary education (%) in Lesotho in 1992 to that in 1993?
Make the answer very short. 0.91. What is the ratio of the Persistence rate to the last grade of primary education (%) in Heavily indebted poor countries in 1992 to that in 1996?
Your response must be concise. 1.03. What is the ratio of the Persistence rate to the last grade of primary education (%) in Botswana in 1992 to that in 1996?
Your response must be concise. 0.9. What is the ratio of the Persistence rate to the last grade of primary education (%) in El Salvador in 1992 to that in 1996?
Keep it short and to the point. 0.97. What is the ratio of the Persistence rate to the last grade of primary education (%) of Lesotho in 1992 to that in 1996?
Give a very brief answer. 0.81. What is the ratio of the Persistence rate to the last grade of primary education (%) in Heavily indebted poor countries in 1992 to that in 2000?
Your response must be concise. 0.79. What is the ratio of the Persistence rate to the last grade of primary education (%) of Botswana in 1992 to that in 2000?
Offer a very short reply. 0.78. What is the ratio of the Persistence rate to the last grade of primary education (%) in El Salvador in 1992 to that in 2000?
Your answer should be very brief. 0.73. What is the ratio of the Persistence rate to the last grade of primary education (%) in Lesotho in 1992 to that in 2000?
Offer a very short reply. 0.78. What is the ratio of the Persistence rate to the last grade of primary education (%) of Heavily indebted poor countries in 1992 to that in 2001?
Your response must be concise. 0.74. What is the ratio of the Persistence rate to the last grade of primary education (%) of Botswana in 1992 to that in 2001?
Provide a short and direct response. 0.78. What is the ratio of the Persistence rate to the last grade of primary education (%) of El Salvador in 1992 to that in 2001?
Make the answer very short. 0.7. What is the ratio of the Persistence rate to the last grade of primary education (%) in Lesotho in 1992 to that in 2001?
Your answer should be very brief. 0.73. What is the ratio of the Persistence rate to the last grade of primary education (%) of Heavily indebted poor countries in 1993 to that in 1996?
Ensure brevity in your answer.  1.04. What is the ratio of the Persistence rate to the last grade of primary education (%) of Botswana in 1993 to that in 1996?
Your answer should be compact. 0.96. What is the ratio of the Persistence rate to the last grade of primary education (%) of El Salvador in 1993 to that in 1996?
Your response must be concise. 1.08. What is the ratio of the Persistence rate to the last grade of primary education (%) of Lesotho in 1993 to that in 1996?
Keep it short and to the point. 0.9. What is the ratio of the Persistence rate to the last grade of primary education (%) of Heavily indebted poor countries in 1993 to that in 2000?
Provide a succinct answer. 0.79. What is the ratio of the Persistence rate to the last grade of primary education (%) of Botswana in 1993 to that in 2000?
Provide a succinct answer. 0.83. What is the ratio of the Persistence rate to the last grade of primary education (%) in El Salvador in 1993 to that in 2000?
Give a very brief answer. 0.81. What is the ratio of the Persistence rate to the last grade of primary education (%) of Lesotho in 1993 to that in 2000?
Ensure brevity in your answer.  0.86. What is the ratio of the Persistence rate to the last grade of primary education (%) in Heavily indebted poor countries in 1993 to that in 2001?
Make the answer very short. 0.74. What is the ratio of the Persistence rate to the last grade of primary education (%) in Botswana in 1993 to that in 2001?
Your answer should be compact. 0.83. What is the ratio of the Persistence rate to the last grade of primary education (%) in El Salvador in 1993 to that in 2001?
Make the answer very short. 0.79. What is the ratio of the Persistence rate to the last grade of primary education (%) of Lesotho in 1993 to that in 2001?
Keep it short and to the point. 0.81. What is the ratio of the Persistence rate to the last grade of primary education (%) in Heavily indebted poor countries in 1996 to that in 2000?
Your response must be concise. 0.76. What is the ratio of the Persistence rate to the last grade of primary education (%) of Botswana in 1996 to that in 2000?
Ensure brevity in your answer.  0.87. What is the ratio of the Persistence rate to the last grade of primary education (%) of El Salvador in 1996 to that in 2000?
Provide a succinct answer. 0.75. What is the ratio of the Persistence rate to the last grade of primary education (%) of Lesotho in 1996 to that in 2000?
Your answer should be compact. 0.96. What is the ratio of the Persistence rate to the last grade of primary education (%) in Heavily indebted poor countries in 1996 to that in 2001?
Offer a terse response. 0.72. What is the ratio of the Persistence rate to the last grade of primary education (%) of Botswana in 1996 to that in 2001?
Offer a terse response. 0.87. What is the ratio of the Persistence rate to the last grade of primary education (%) in El Salvador in 1996 to that in 2001?
Provide a succinct answer. 0.73. What is the ratio of the Persistence rate to the last grade of primary education (%) in Lesotho in 1996 to that in 2001?
Your answer should be compact. 0.9. What is the ratio of the Persistence rate to the last grade of primary education (%) of Heavily indebted poor countries in 2000 to that in 2001?
Your response must be concise. 0.94. What is the ratio of the Persistence rate to the last grade of primary education (%) in Botswana in 2000 to that in 2001?
Your answer should be compact. 1. What is the ratio of the Persistence rate to the last grade of primary education (%) in El Salvador in 2000 to that in 2001?
Keep it short and to the point. 0.97. What is the ratio of the Persistence rate to the last grade of primary education (%) of Lesotho in 2000 to that in 2001?
Your answer should be compact. 0.93. What is the difference between the highest and the second highest Persistence rate to the last grade of primary education (%) of Heavily indebted poor countries?
Ensure brevity in your answer.  3.8. What is the difference between the highest and the second highest Persistence rate to the last grade of primary education (%) in Botswana?
Your answer should be compact. 0.08. What is the difference between the highest and the second highest Persistence rate to the last grade of primary education (%) of El Salvador?
Your response must be concise. 2.15. What is the difference between the highest and the second highest Persistence rate to the last grade of primary education (%) of Lesotho?
Provide a succinct answer. 3.34. What is the difference between the highest and the lowest Persistence rate to the last grade of primary education (%) of Heavily indebted poor countries?
Ensure brevity in your answer.  18.11. What is the difference between the highest and the lowest Persistence rate to the last grade of primary education (%) of Botswana?
Offer a very short reply. 23.69. What is the difference between the highest and the lowest Persistence rate to the last grade of primary education (%) of El Salvador?
Provide a succinct answer. 23.05. What is the difference between the highest and the lowest Persistence rate to the last grade of primary education (%) of Lesotho?
Make the answer very short. 22.84. 